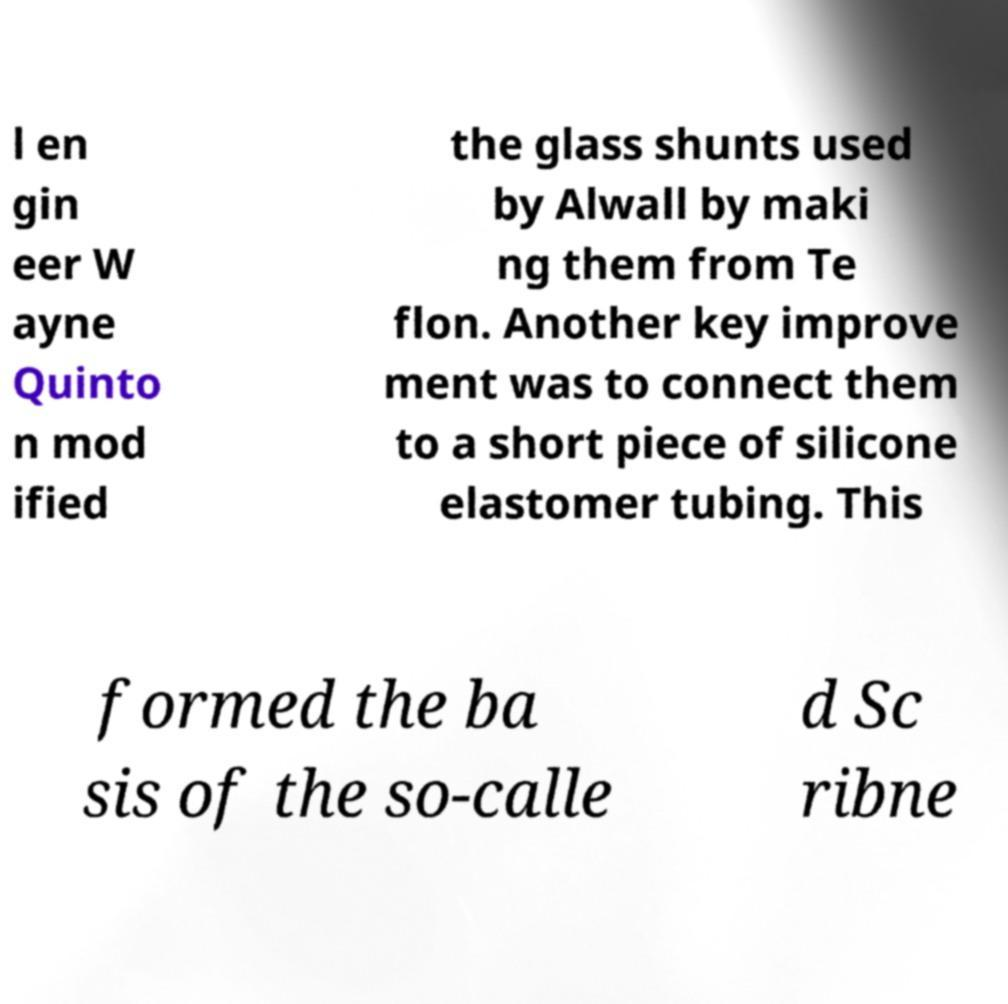There's text embedded in this image that I need extracted. Can you transcribe it verbatim? l en gin eer W ayne Quinto n mod ified the glass shunts used by Alwall by maki ng them from Te flon. Another key improve ment was to connect them to a short piece of silicone elastomer tubing. This formed the ba sis of the so-calle d Sc ribne 